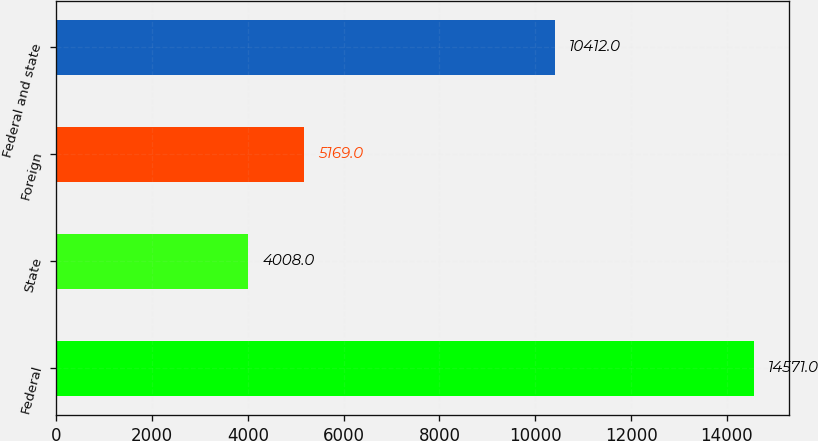Convert chart to OTSL. <chart><loc_0><loc_0><loc_500><loc_500><bar_chart><fcel>Federal<fcel>State<fcel>Foreign<fcel>Federal and state<nl><fcel>14571<fcel>4008<fcel>5169<fcel>10412<nl></chart> 